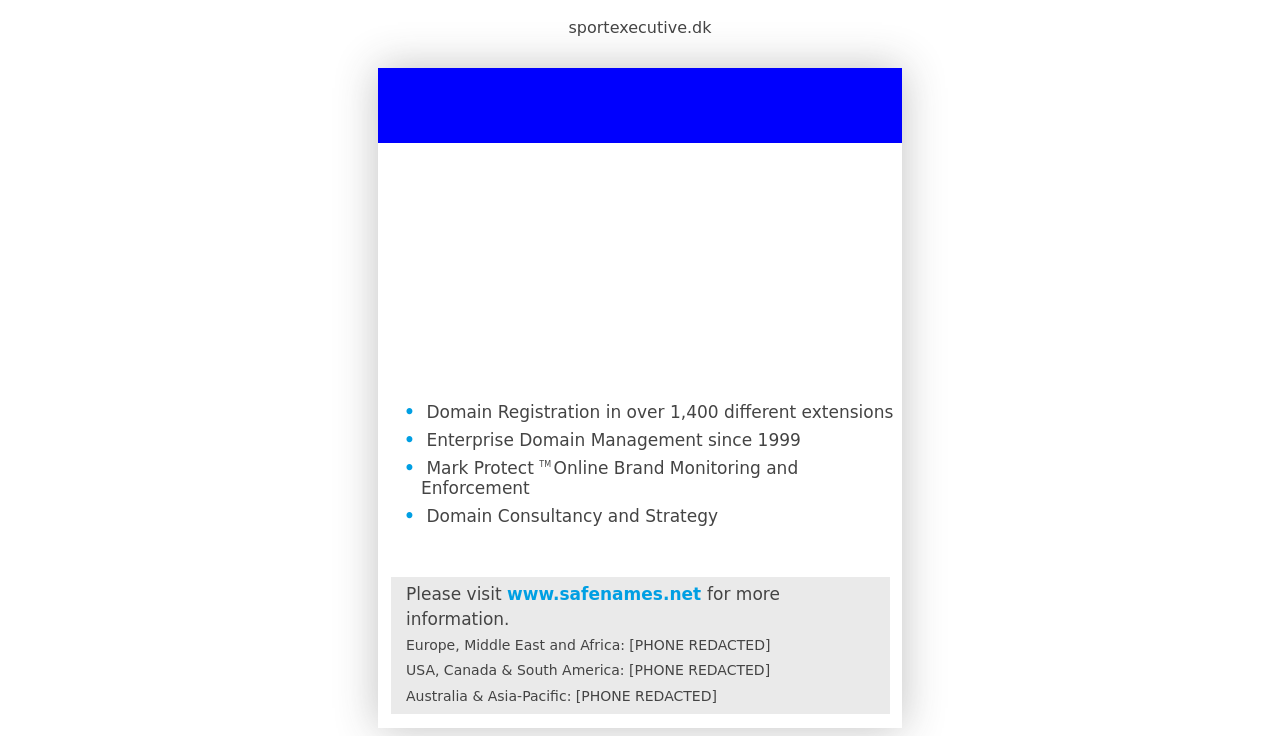Can you explain the significance of the services listed on this website? Certainly! The website mentions several key services related to domain management and online branding. 'Domain Registration' implies that they offer a wide range of domain extensions, ensuring flexibility and choice for global businesses. 'Enterprise Domain Management' indicates a robust support system for managing large portfolios of domain names since 1999, showing extensive experience. 'Mark Protect™ Online Brand Monitoring and Enforcement' involves tools and strategies to protect a brand online, ensuring that only authorized use of the brand occurs across digital platforms. Lastly, 'Domain Consultancy and Strategy' suggests they provide expert advice on how to effectively use and secure domain names as part of broader business strategies. 